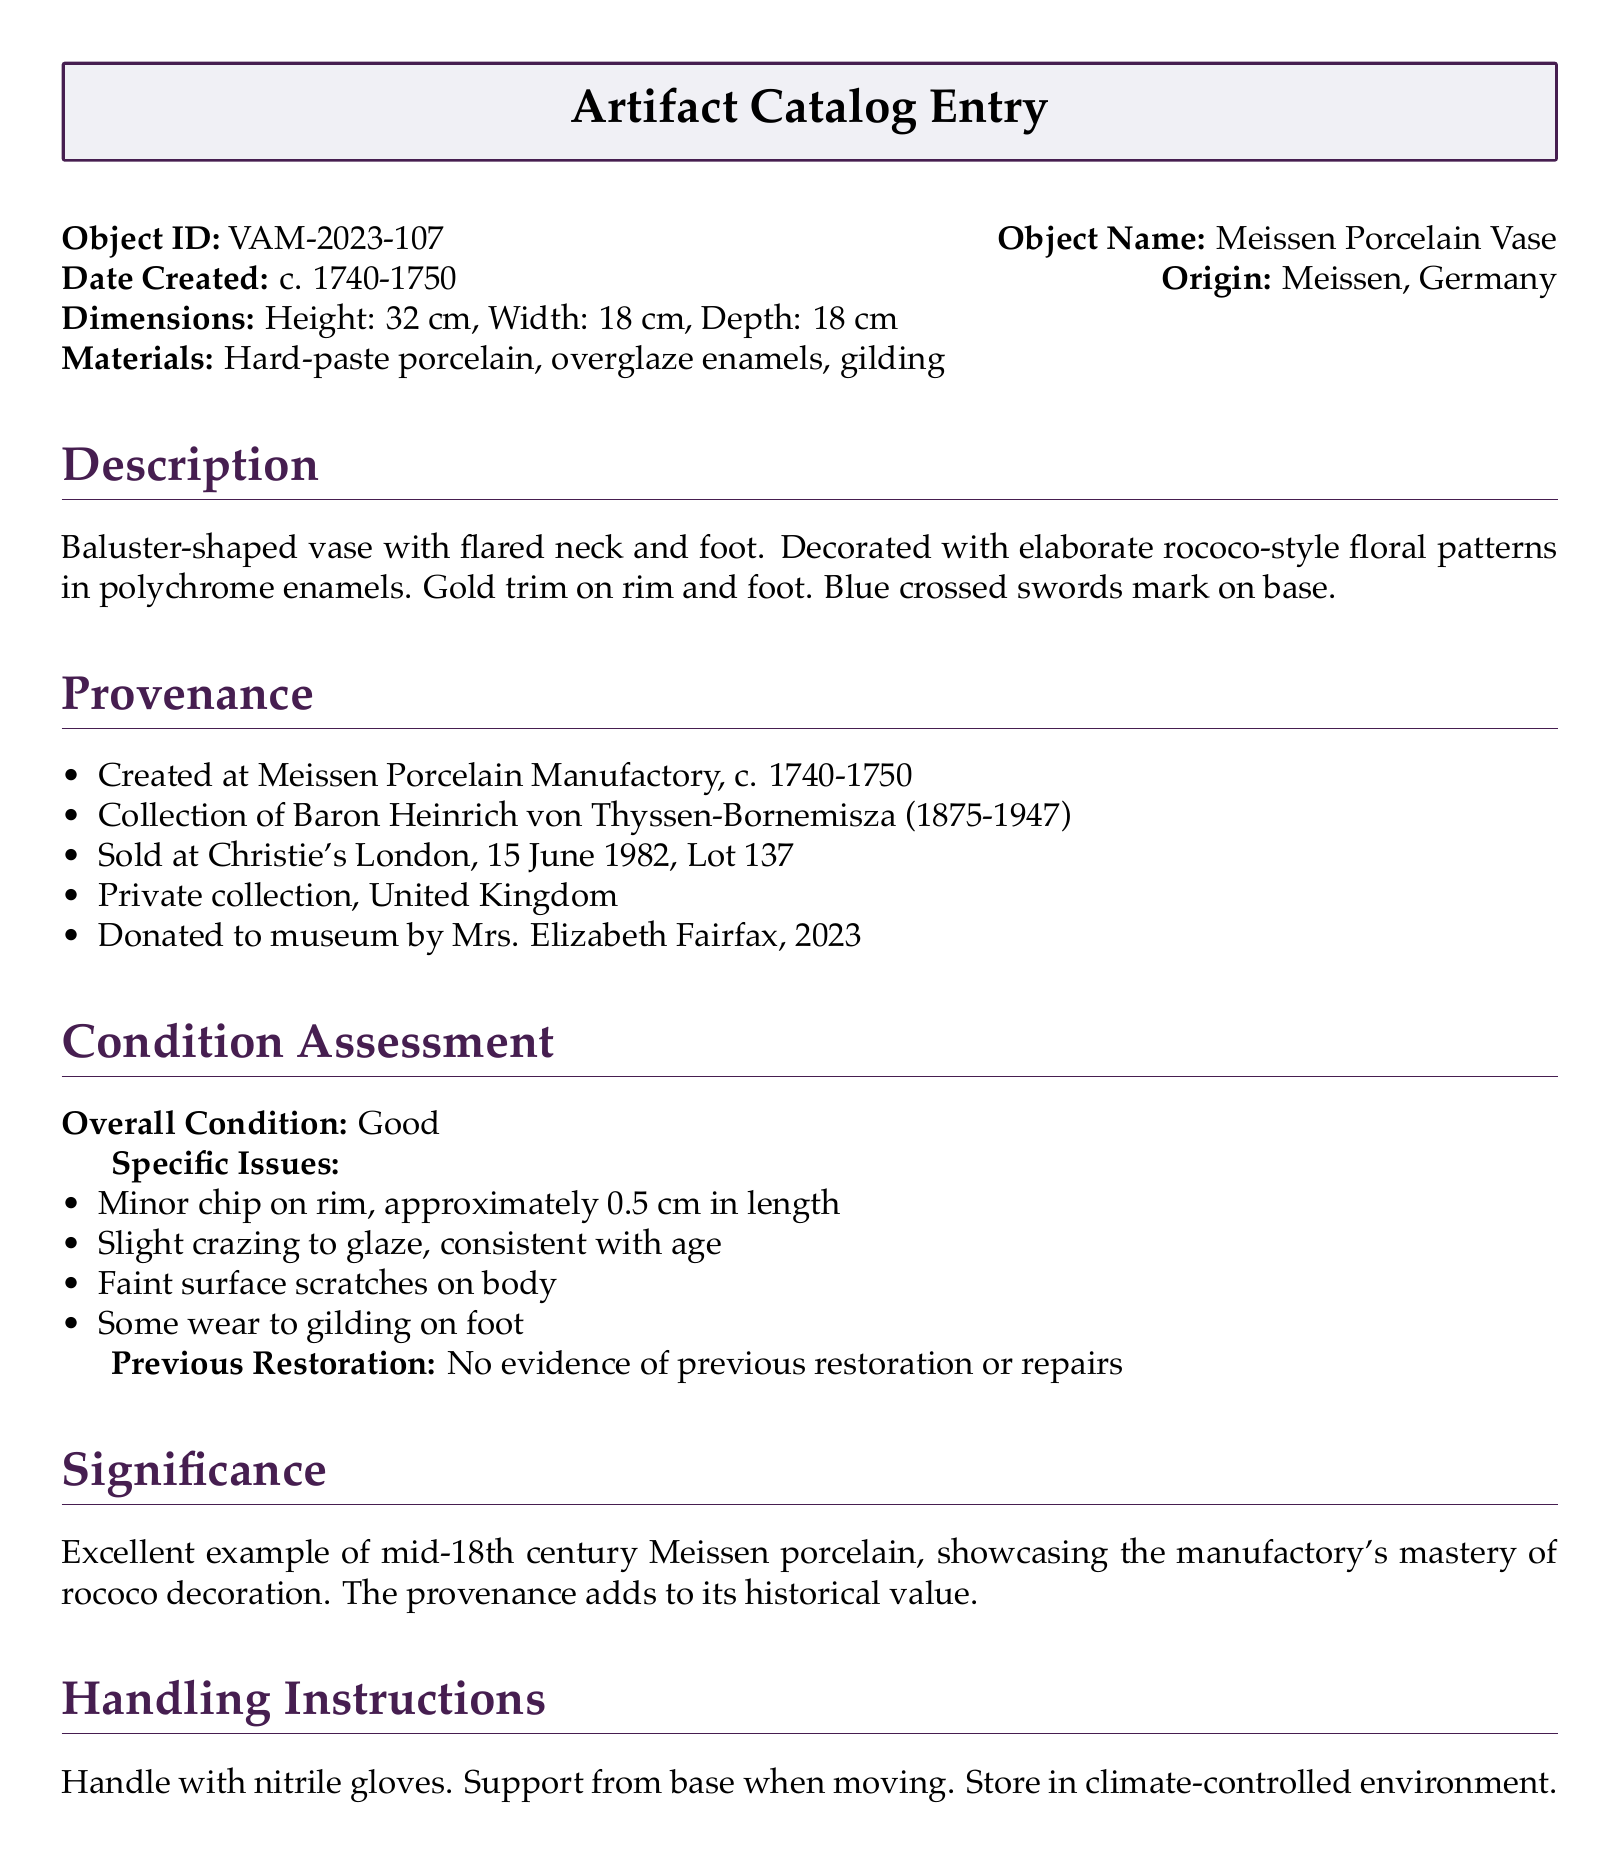What is the object ID? The object ID is a unique identifier for the catalog entry, which is provided in the document.
Answer: VAM-2023-107 What is the date created? The date created indicates when the vase was produced, as mentioned in the document.
Answer: c. 1740-1750 What is the overall condition of the vase? The overall condition is a summary of the vase's state as assessed in the document.
Answer: Good Who donated the vase to the museum? The document states the name of the person who donated the artifact to the museum.
Answer: Mrs. Elizabeth Fairfax What are the specific issues found in the vase? The specific issues outline the minor damages seen in the vase according to the condition assessment.
Answer: Minor chip on rim, slight crazing, faint surface scratches, wear to gilding What is the significance of the vase? The significance explains why the vase is historically important, based on the text provided.
Answer: Excellent example of mid-18th century Meissen porcelain Where was the vase created? The document specifies the origin of the vase, which is essential for understanding its background.
Answer: Meissen, Germany What material is the vase made of? The materials section details the composition of the vase as listed in the document.
Answer: Hard-paste porcelain, overglaze enamels, gilding What are the handling instructions for the vase? The handling instructions provide guidance on how to properly manage the vase based on the document's information.
Answer: Handle with nitrile gloves. Support from base when moving. Store in climate-controlled environment 